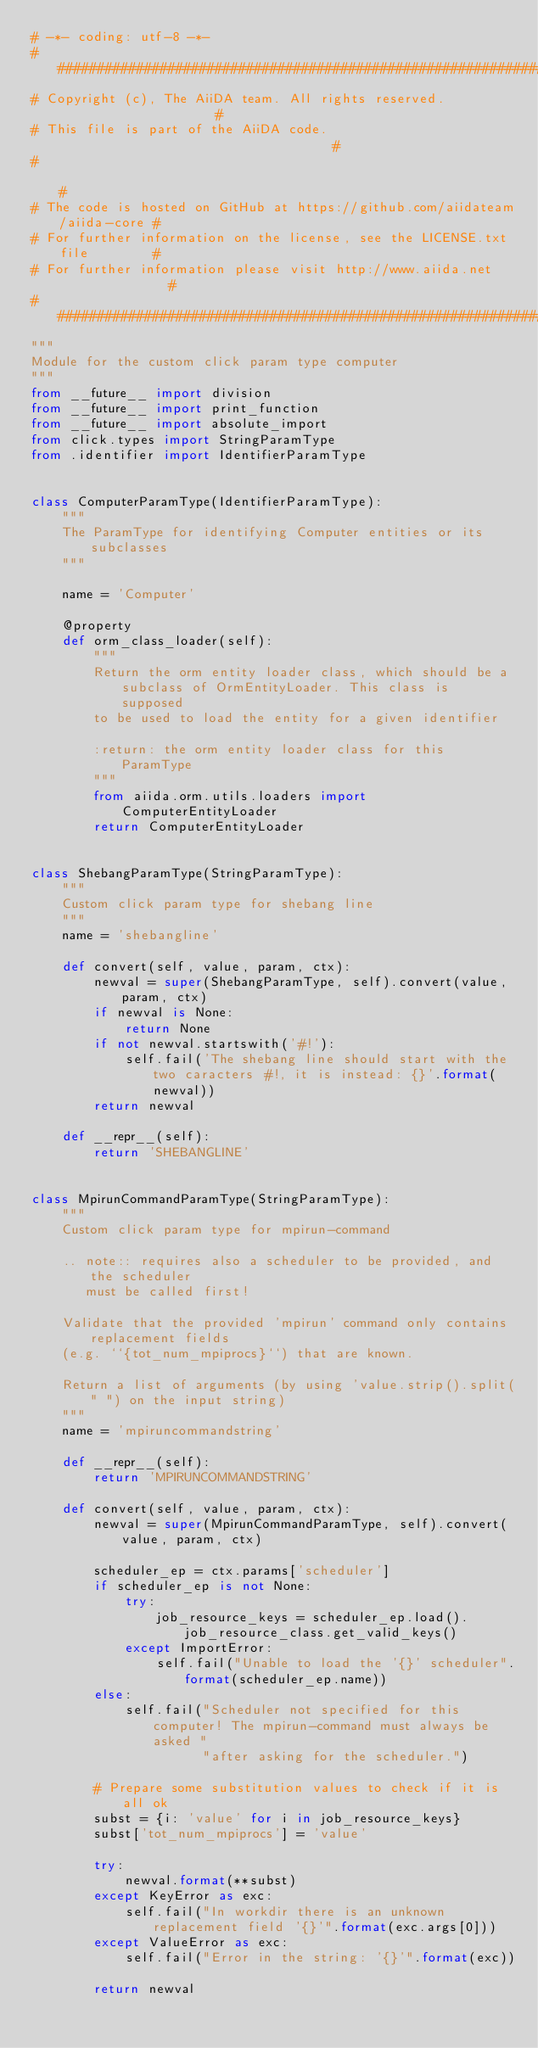Convert code to text. <code><loc_0><loc_0><loc_500><loc_500><_Python_># -*- coding: utf-8 -*-
###########################################################################
# Copyright (c), The AiiDA team. All rights reserved.                     #
# This file is part of the AiiDA code.                                    #
#                                                                         #
# The code is hosted on GitHub at https://github.com/aiidateam/aiida-core #
# For further information on the license, see the LICENSE.txt file        #
# For further information please visit http://www.aiida.net               #
###########################################################################
"""
Module for the custom click param type computer
"""
from __future__ import division
from __future__ import print_function
from __future__ import absolute_import
from click.types import StringParamType
from .identifier import IdentifierParamType


class ComputerParamType(IdentifierParamType):
    """
    The ParamType for identifying Computer entities or its subclasses
    """

    name = 'Computer'

    @property
    def orm_class_loader(self):
        """
        Return the orm entity loader class, which should be a subclass of OrmEntityLoader. This class is supposed
        to be used to load the entity for a given identifier

        :return: the orm entity loader class for this ParamType
        """
        from aiida.orm.utils.loaders import ComputerEntityLoader
        return ComputerEntityLoader


class ShebangParamType(StringParamType):
    """
    Custom click param type for shebang line
    """
    name = 'shebangline'

    def convert(self, value, param, ctx):
        newval = super(ShebangParamType, self).convert(value, param, ctx)
        if newval is None:
            return None
        if not newval.startswith('#!'):
            self.fail('The shebang line should start with the two caracters #!, it is instead: {}'.format(newval))
        return newval

    def __repr__(self):
        return 'SHEBANGLINE'


class MpirunCommandParamType(StringParamType):
    """
    Custom click param type for mpirun-command

    .. note:: requires also a scheduler to be provided, and the scheduler
       must be called first!

    Validate that the provided 'mpirun' command only contains replacement fields
    (e.g. ``{tot_num_mpiprocs}``) that are known.

    Return a list of arguments (by using 'value.strip().split(" ") on the input string)
    """
    name = 'mpiruncommandstring'

    def __repr__(self):
        return 'MPIRUNCOMMANDSTRING'

    def convert(self, value, param, ctx):
        newval = super(MpirunCommandParamType, self).convert(value, param, ctx)

        scheduler_ep = ctx.params['scheduler']
        if scheduler_ep is not None:
            try:
                job_resource_keys = scheduler_ep.load().job_resource_class.get_valid_keys()
            except ImportError:
                self.fail("Unable to load the '{}' scheduler".format(scheduler_ep.name))
        else:
            self.fail("Scheduler not specified for this computer! The mpirun-command must always be asked "
                      "after asking for the scheduler.")

        # Prepare some substitution values to check if it is all ok
        subst = {i: 'value' for i in job_resource_keys}
        subst['tot_num_mpiprocs'] = 'value'

        try:
            newval.format(**subst)
        except KeyError as exc:
            self.fail("In workdir there is an unknown replacement field '{}'".format(exc.args[0]))
        except ValueError as exc:
            self.fail("Error in the string: '{}'".format(exc))

        return newval
</code> 